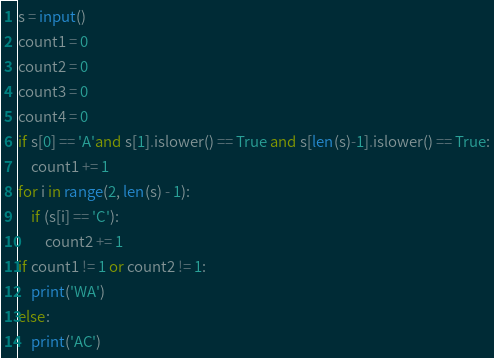Convert code to text. <code><loc_0><loc_0><loc_500><loc_500><_Python_>s = input()
count1 = 0
count2 = 0
count3 = 0
count4 = 0
if s[0] == 'A'and s[1].islower() == True and s[len(s)-1].islower() == True:
    count1 += 1
for i in range(2, len(s) - 1):
    if (s[i] == 'C'):
        count2 += 1
if count1 != 1 or count2 != 1:
    print('WA')
else:
    print('AC')

</code> 